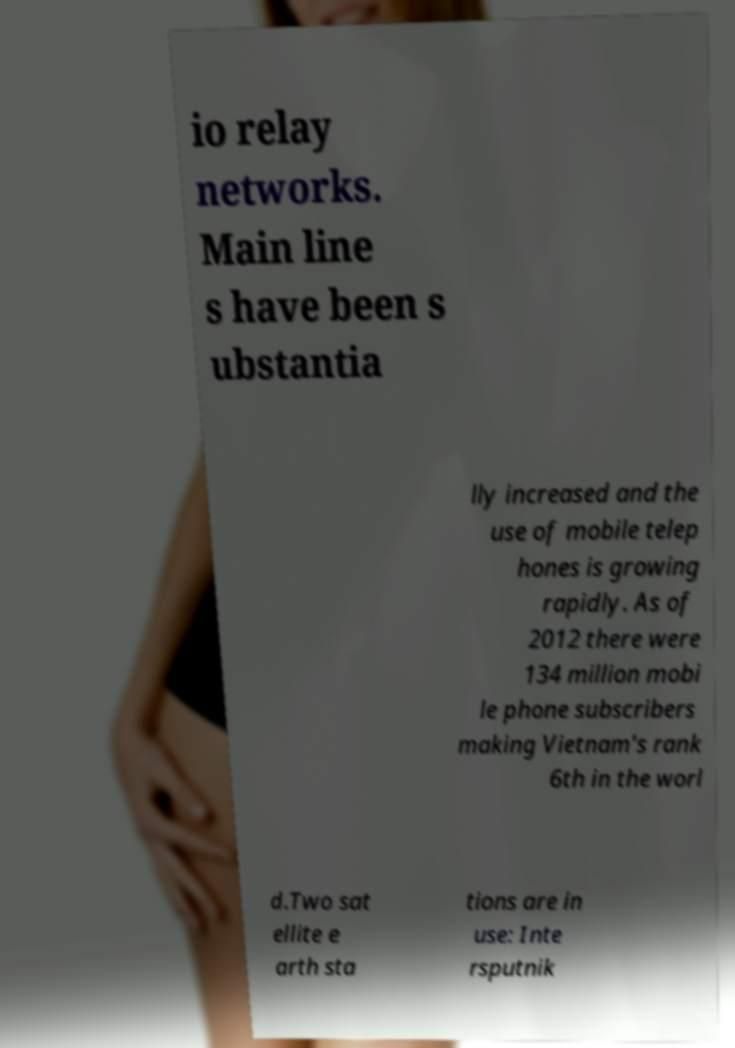For documentation purposes, I need the text within this image transcribed. Could you provide that? io relay networks. Main line s have been s ubstantia lly increased and the use of mobile telep hones is growing rapidly. As of 2012 there were 134 million mobi le phone subscribers making Vietnam's rank 6th in the worl d.Two sat ellite e arth sta tions are in use: Inte rsputnik 